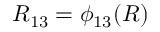Convert formula to latex. <formula><loc_0><loc_0><loc_500><loc_500>R _ { 1 3 } = \phi _ { 1 3 } ( R )</formula> 